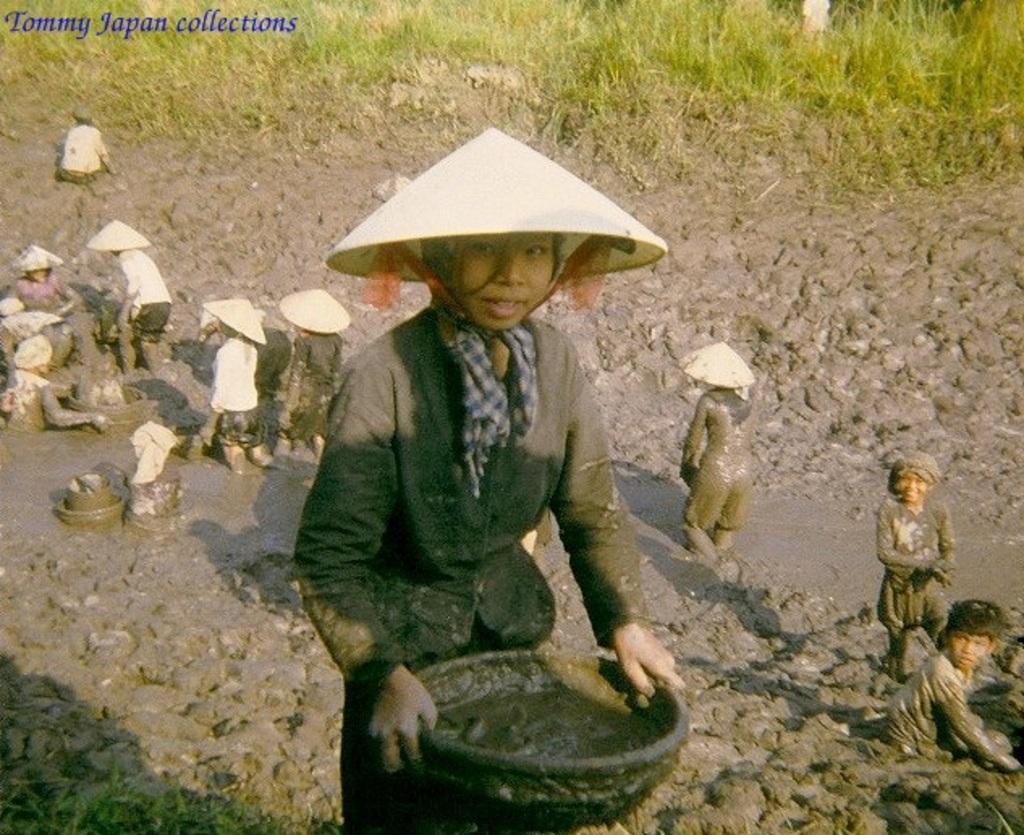Please provide a concise description of this image. In this picture I can see few persons, they are wearing the caps, in the top left hand side there is the text. At the top there are plants. 